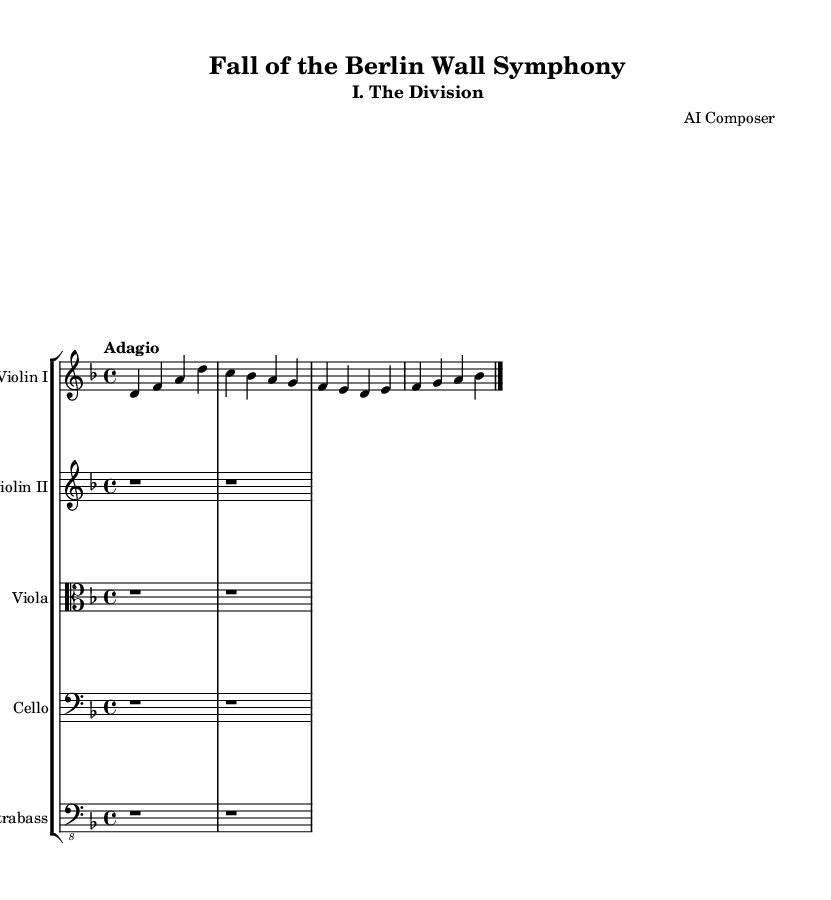What is the key signature of this music? The key signature is D minor, which has one flat (B flat). This can be determined from the key indicated at the beginning of the score.
Answer: D minor What is the time signature of this music? The time signature is 4/4, which means there are four beats in a measure and the quarter note receives one beat. This is stated at the start of the score.
Answer: 4/4 What is the tempo marking for this piece? The tempo marking is Adagio, indicating a slow tempo. This can be found written at the beginning of the score next to the time signature.
Answer: Adagio Which instruments are featured in this score? The score features Violin I, Violin II, Viola, Cello, and Contrabass. This is evident from the staff group headers provided in the score layout.
Answer: Violin I, Violin II, Viola, Cello, Contrabass What is the melodic pitch of the first note in the main theme? The first note of the main theme is D4, which is the first note noted in the Violin I part. This is found at the beginning of the mainTheme notation.
Answer: D4 Why are the parts for Violin II, Viola, Cello, and Contrabass represented by rest notes? The parts for the other instruments are represented by rest notes because they are not playing during the main theme, as indicated by the notation showing only rest symbols without note values. This suggests they may join later.
Answer: Rest 